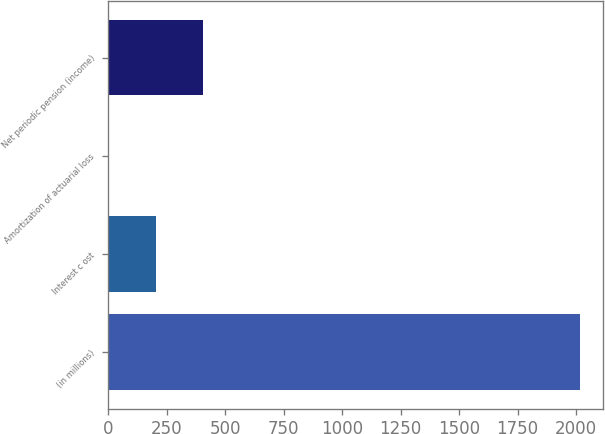Convert chart to OTSL. <chart><loc_0><loc_0><loc_500><loc_500><bar_chart><fcel>(in millions)<fcel>Interest c ost<fcel>Amortization of actuarial loss<fcel>Net periodic pension (income)<nl><fcel>2016<fcel>203.4<fcel>2<fcel>404.8<nl></chart> 